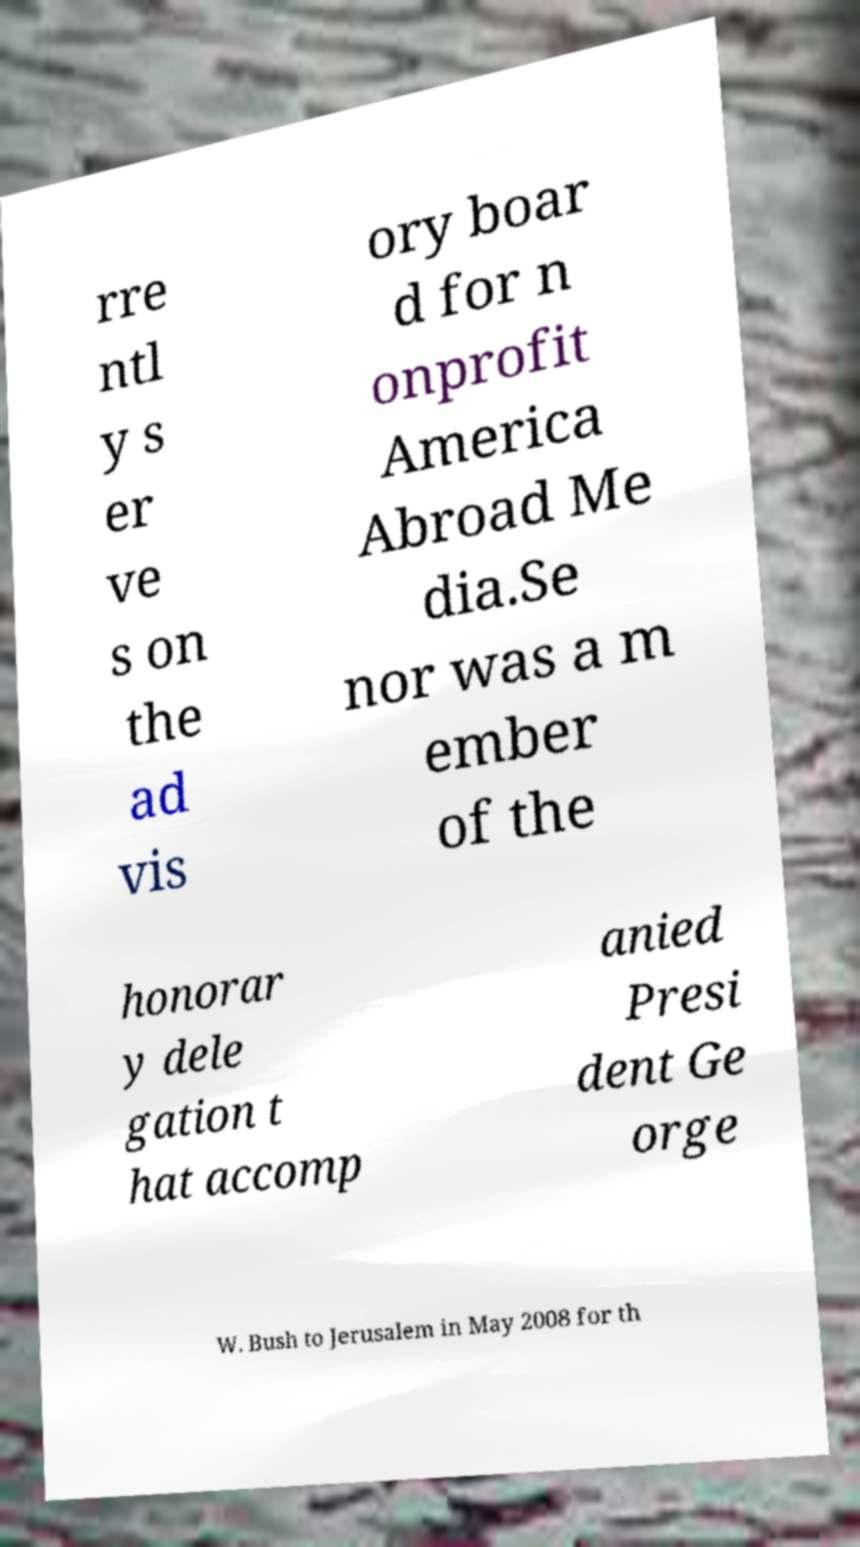I need the written content from this picture converted into text. Can you do that? rre ntl y s er ve s on the ad vis ory boar d for n onprofit America Abroad Me dia.Se nor was a m ember of the honorar y dele gation t hat accomp anied Presi dent Ge orge W. Bush to Jerusalem in May 2008 for th 